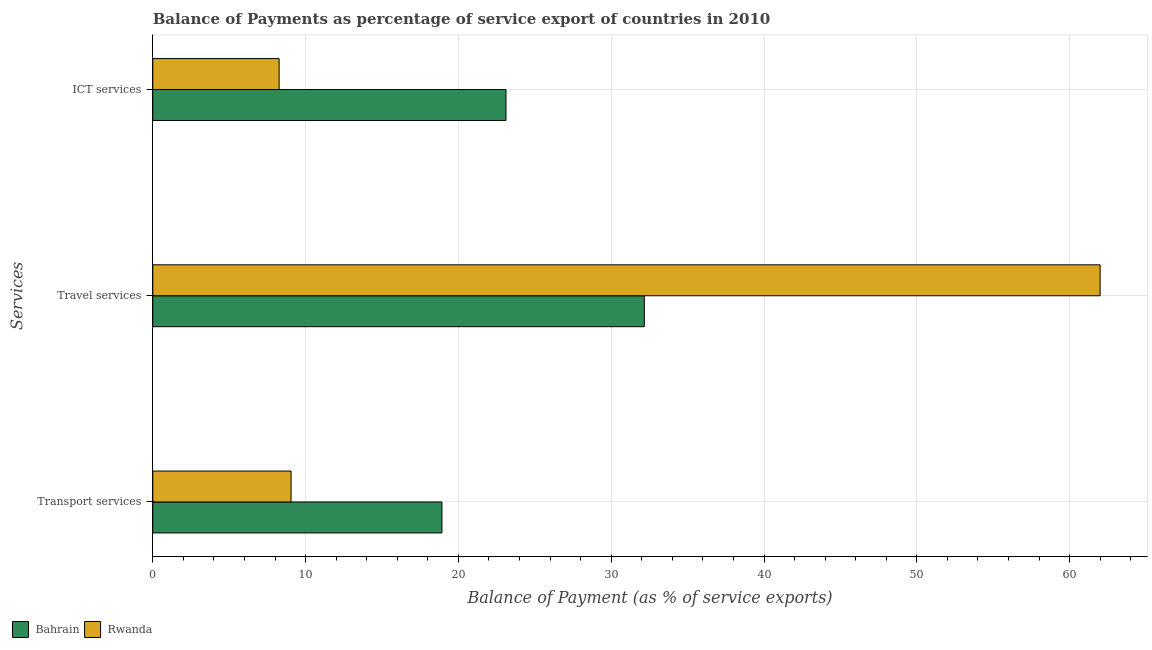How many different coloured bars are there?
Provide a short and direct response. 2. Are the number of bars per tick equal to the number of legend labels?
Your response must be concise. Yes. Are the number of bars on each tick of the Y-axis equal?
Keep it short and to the point. Yes. What is the label of the 2nd group of bars from the top?
Your answer should be compact. Travel services. What is the balance of payment of transport services in Bahrain?
Your answer should be compact. 18.92. Across all countries, what is the maximum balance of payment of ict services?
Offer a terse response. 23.11. Across all countries, what is the minimum balance of payment of transport services?
Offer a very short reply. 9.05. In which country was the balance of payment of ict services maximum?
Make the answer very short. Bahrain. In which country was the balance of payment of transport services minimum?
Offer a terse response. Rwanda. What is the total balance of payment of transport services in the graph?
Provide a short and direct response. 27.97. What is the difference between the balance of payment of ict services in Rwanda and that in Bahrain?
Offer a terse response. -14.85. What is the difference between the balance of payment of travel services in Rwanda and the balance of payment of transport services in Bahrain?
Keep it short and to the point. 43.07. What is the average balance of payment of transport services per country?
Offer a terse response. 13.99. What is the difference between the balance of payment of ict services and balance of payment of travel services in Bahrain?
Give a very brief answer. -9.05. What is the ratio of the balance of payment of ict services in Bahrain to that in Rwanda?
Ensure brevity in your answer.  2.8. Is the balance of payment of ict services in Bahrain less than that in Rwanda?
Your answer should be compact. No. What is the difference between the highest and the second highest balance of payment of transport services?
Offer a terse response. 9.87. What is the difference between the highest and the lowest balance of payment of travel services?
Your response must be concise. 29.83. What does the 2nd bar from the top in ICT services represents?
Ensure brevity in your answer.  Bahrain. What does the 1st bar from the bottom in ICT services represents?
Your answer should be compact. Bahrain. Does the graph contain any zero values?
Provide a short and direct response. No. Where does the legend appear in the graph?
Provide a short and direct response. Bottom left. What is the title of the graph?
Offer a very short reply. Balance of Payments as percentage of service export of countries in 2010. What is the label or title of the X-axis?
Your answer should be very brief. Balance of Payment (as % of service exports). What is the label or title of the Y-axis?
Your response must be concise. Services. What is the Balance of Payment (as % of service exports) of Bahrain in Transport services?
Keep it short and to the point. 18.92. What is the Balance of Payment (as % of service exports) of Rwanda in Transport services?
Ensure brevity in your answer.  9.05. What is the Balance of Payment (as % of service exports) of Bahrain in Travel services?
Provide a succinct answer. 32.17. What is the Balance of Payment (as % of service exports) in Rwanda in Travel services?
Offer a very short reply. 61.99. What is the Balance of Payment (as % of service exports) of Bahrain in ICT services?
Your answer should be very brief. 23.11. What is the Balance of Payment (as % of service exports) of Rwanda in ICT services?
Make the answer very short. 8.27. Across all Services, what is the maximum Balance of Payment (as % of service exports) in Bahrain?
Keep it short and to the point. 32.17. Across all Services, what is the maximum Balance of Payment (as % of service exports) of Rwanda?
Provide a succinct answer. 61.99. Across all Services, what is the minimum Balance of Payment (as % of service exports) of Bahrain?
Provide a short and direct response. 18.92. Across all Services, what is the minimum Balance of Payment (as % of service exports) in Rwanda?
Offer a terse response. 8.27. What is the total Balance of Payment (as % of service exports) in Bahrain in the graph?
Offer a terse response. 74.2. What is the total Balance of Payment (as % of service exports) in Rwanda in the graph?
Provide a succinct answer. 79.31. What is the difference between the Balance of Payment (as % of service exports) of Bahrain in Transport services and that in Travel services?
Keep it short and to the point. -13.24. What is the difference between the Balance of Payment (as % of service exports) of Rwanda in Transport services and that in Travel services?
Provide a short and direct response. -52.94. What is the difference between the Balance of Payment (as % of service exports) of Bahrain in Transport services and that in ICT services?
Your answer should be very brief. -4.19. What is the difference between the Balance of Payment (as % of service exports) of Rwanda in Transport services and that in ICT services?
Your answer should be compact. 0.78. What is the difference between the Balance of Payment (as % of service exports) in Bahrain in Travel services and that in ICT services?
Offer a very short reply. 9.05. What is the difference between the Balance of Payment (as % of service exports) in Rwanda in Travel services and that in ICT services?
Make the answer very short. 53.73. What is the difference between the Balance of Payment (as % of service exports) of Bahrain in Transport services and the Balance of Payment (as % of service exports) of Rwanda in Travel services?
Your response must be concise. -43.07. What is the difference between the Balance of Payment (as % of service exports) in Bahrain in Transport services and the Balance of Payment (as % of service exports) in Rwanda in ICT services?
Your response must be concise. 10.65. What is the difference between the Balance of Payment (as % of service exports) in Bahrain in Travel services and the Balance of Payment (as % of service exports) in Rwanda in ICT services?
Ensure brevity in your answer.  23.9. What is the average Balance of Payment (as % of service exports) in Bahrain per Services?
Give a very brief answer. 24.73. What is the average Balance of Payment (as % of service exports) of Rwanda per Services?
Your answer should be very brief. 26.44. What is the difference between the Balance of Payment (as % of service exports) of Bahrain and Balance of Payment (as % of service exports) of Rwanda in Transport services?
Make the answer very short. 9.87. What is the difference between the Balance of Payment (as % of service exports) in Bahrain and Balance of Payment (as % of service exports) in Rwanda in Travel services?
Offer a very short reply. -29.83. What is the difference between the Balance of Payment (as % of service exports) in Bahrain and Balance of Payment (as % of service exports) in Rwanda in ICT services?
Your answer should be very brief. 14.85. What is the ratio of the Balance of Payment (as % of service exports) in Bahrain in Transport services to that in Travel services?
Your answer should be very brief. 0.59. What is the ratio of the Balance of Payment (as % of service exports) of Rwanda in Transport services to that in Travel services?
Your answer should be compact. 0.15. What is the ratio of the Balance of Payment (as % of service exports) in Bahrain in Transport services to that in ICT services?
Ensure brevity in your answer.  0.82. What is the ratio of the Balance of Payment (as % of service exports) in Rwanda in Transport services to that in ICT services?
Ensure brevity in your answer.  1.09. What is the ratio of the Balance of Payment (as % of service exports) of Bahrain in Travel services to that in ICT services?
Offer a terse response. 1.39. What is the ratio of the Balance of Payment (as % of service exports) of Rwanda in Travel services to that in ICT services?
Your response must be concise. 7.5. What is the difference between the highest and the second highest Balance of Payment (as % of service exports) in Bahrain?
Your response must be concise. 9.05. What is the difference between the highest and the second highest Balance of Payment (as % of service exports) of Rwanda?
Provide a short and direct response. 52.94. What is the difference between the highest and the lowest Balance of Payment (as % of service exports) in Bahrain?
Provide a short and direct response. 13.24. What is the difference between the highest and the lowest Balance of Payment (as % of service exports) of Rwanda?
Offer a very short reply. 53.73. 